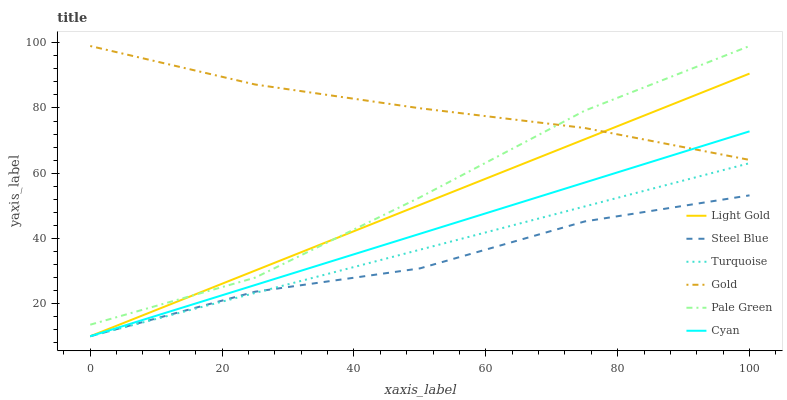Does Steel Blue have the minimum area under the curve?
Answer yes or no. Yes. Does Gold have the maximum area under the curve?
Answer yes or no. Yes. Does Gold have the minimum area under the curve?
Answer yes or no. No. Does Steel Blue have the maximum area under the curve?
Answer yes or no. No. Is Turquoise the smoothest?
Answer yes or no. Yes. Is Steel Blue the roughest?
Answer yes or no. Yes. Is Gold the smoothest?
Answer yes or no. No. Is Gold the roughest?
Answer yes or no. No. Does Turquoise have the lowest value?
Answer yes or no. Yes. Does Gold have the lowest value?
Answer yes or no. No. Does Pale Green have the highest value?
Answer yes or no. Yes. Does Steel Blue have the highest value?
Answer yes or no. No. Is Turquoise less than Gold?
Answer yes or no. Yes. Is Pale Green greater than Cyan?
Answer yes or no. Yes. Does Gold intersect Light Gold?
Answer yes or no. Yes. Is Gold less than Light Gold?
Answer yes or no. No. Is Gold greater than Light Gold?
Answer yes or no. No. Does Turquoise intersect Gold?
Answer yes or no. No. 